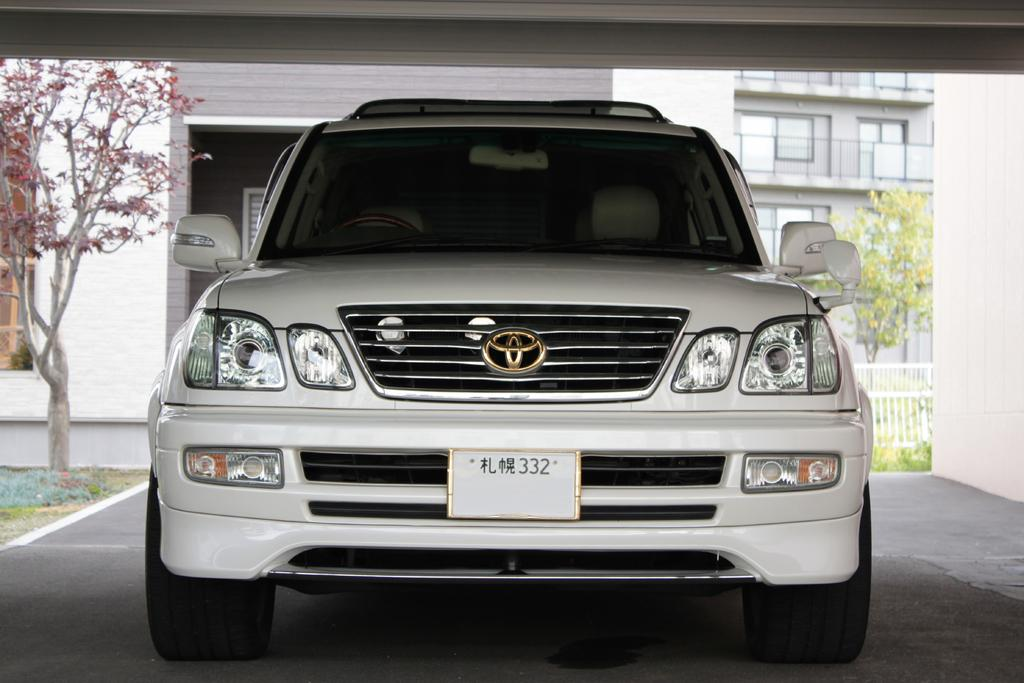What is parked in the image? There is a vehicle parked in the image. What can be seen in the background behind the vehicle? There are buildings visible behind the vehicle. What type of barrier is present in the image? There is fencing in the image. What type of vegetation is present in the image? There are trees in the image. How many lizards are sitting on the crate in the image? There is no crate or lizards present in the image. What advice does the mother give to her child in the image? There is no mother or child present in the image. 